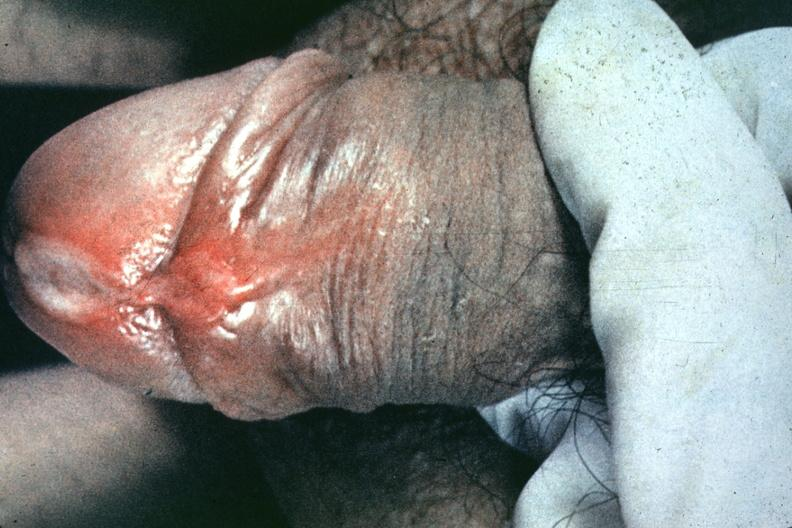s chancre present?
Answer the question using a single word or phrase. Yes 